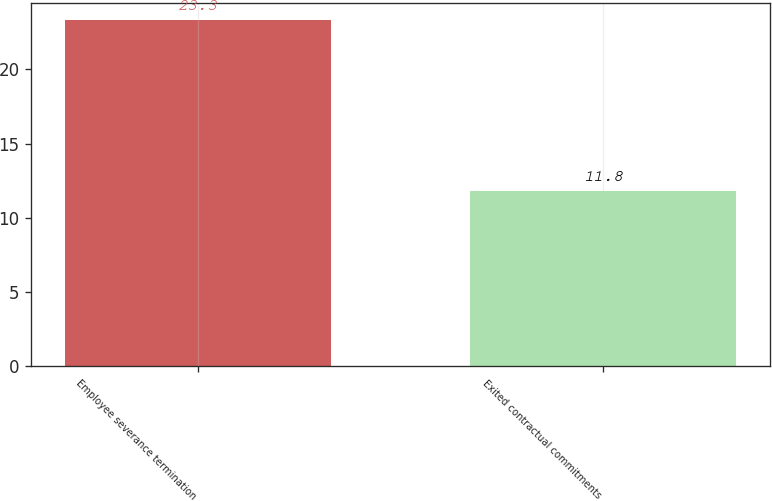<chart> <loc_0><loc_0><loc_500><loc_500><bar_chart><fcel>Employee severance termination<fcel>Exited contractual commitments<nl><fcel>23.3<fcel>11.8<nl></chart> 